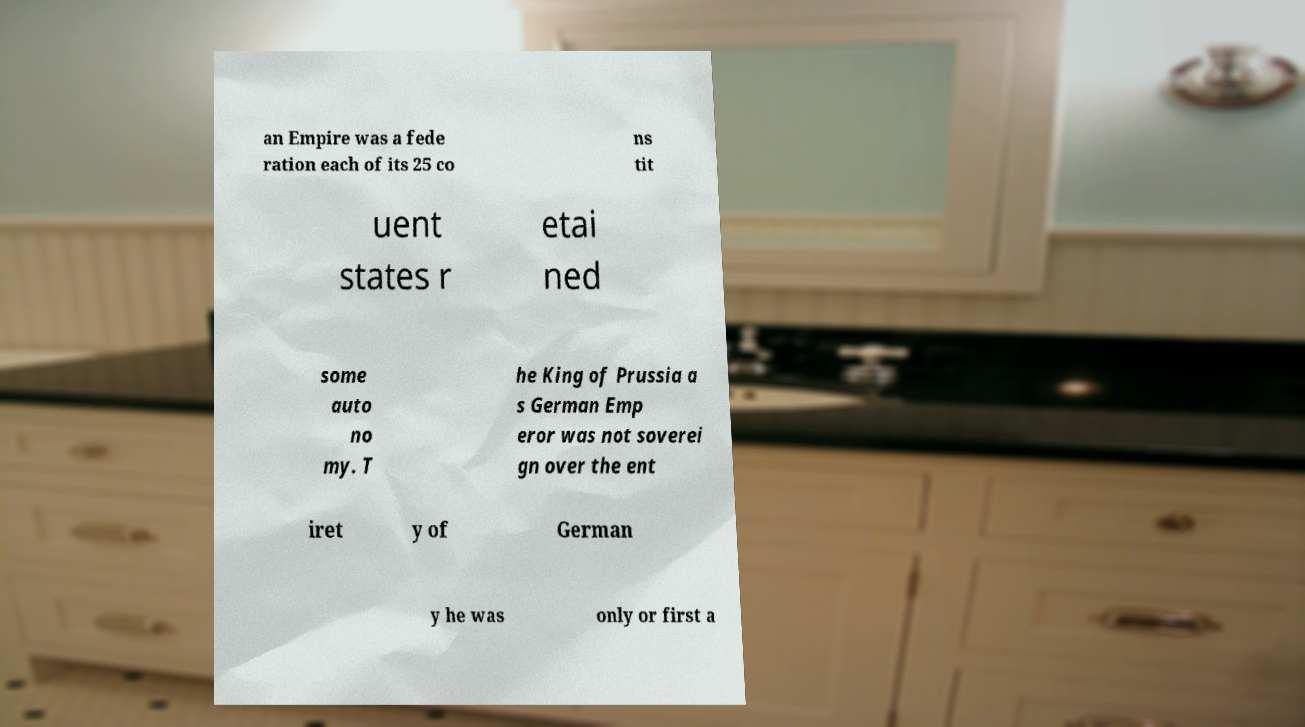Can you read and provide the text displayed in the image?This photo seems to have some interesting text. Can you extract and type it out for me? an Empire was a fede ration each of its 25 co ns tit uent states r etai ned some auto no my. T he King of Prussia a s German Emp eror was not soverei gn over the ent iret y of German y he was only or first a 